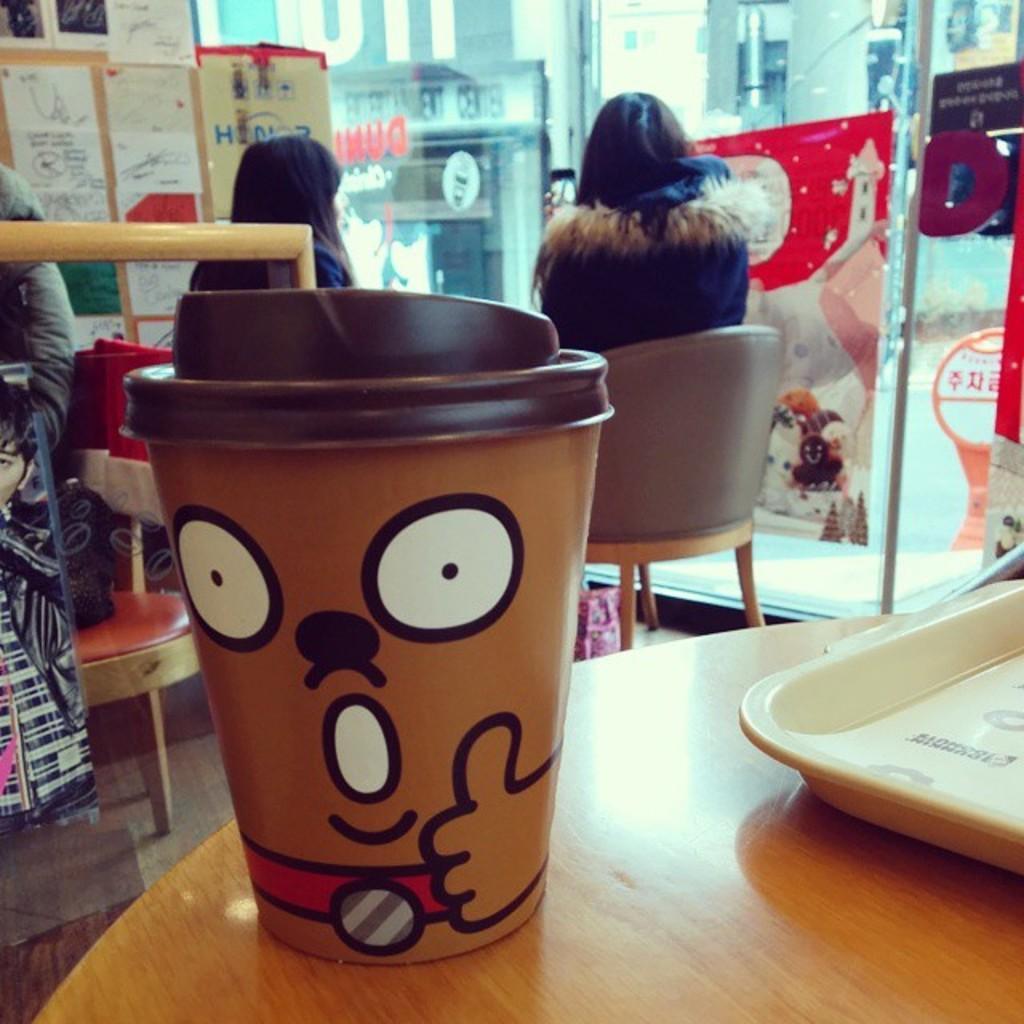Can you describe this image briefly? As we can see in the image there is a table and two people sitting over here and on table there is a tray and glass and on the left side there are posters. 